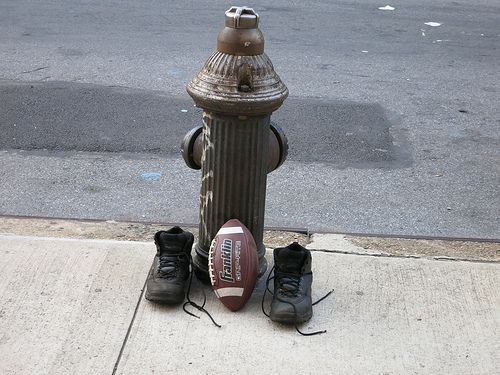<image>
Can you confirm if the football is in front of the fire hydrant? Yes. The football is positioned in front of the fire hydrant, appearing closer to the camera viewpoint. 